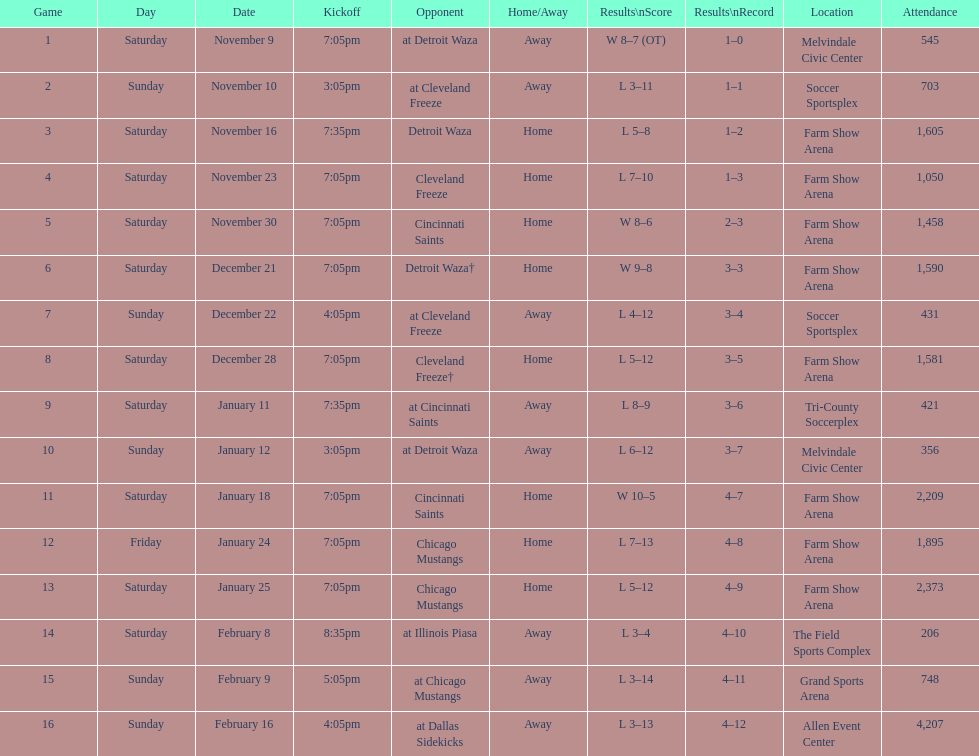What is the date of the game after december 22? December 28. 